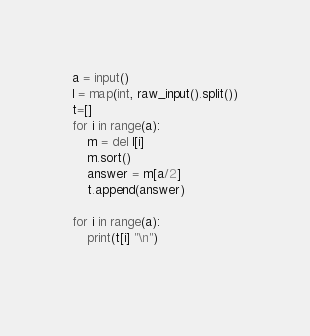Convert code to text. <code><loc_0><loc_0><loc_500><loc_500><_Python_>a = input()
l = map(int, raw_input().split())
t=[]
for i in range(a):
    m = del l[i]
    m.sort()
    answer = m[a/2]
    t.append(answer)

for i in range(a):
    print(t[i] "\n")
    </code> 